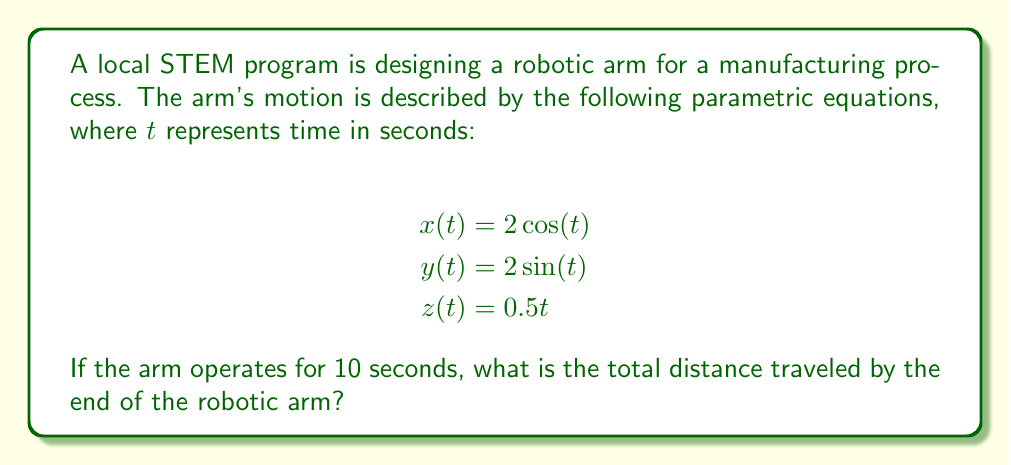Give your solution to this math problem. To solve this problem, we need to follow these steps:

1) The parametric equations describe a helical path in 3D space. We need to calculate the length of this path.

2) For a parametric curve, the arc length $L$ from $t=a$ to $t=b$ is given by:

   $$L = \int_a^b \sqrt{\left(\frac{dx}{dt}\right)^2 + \left(\frac{dy}{dt}\right)^2 + \left(\frac{dz}{dt}\right)^2} dt$$

3) Let's calculate the derivatives:
   $$\frac{dx}{dt} = -2\sin(t)$$
   $$\frac{dy}{dt} = 2\cos(t)$$
   $$\frac{dz}{dt} = 0.5$$

4) Now, let's substitute these into our integral:

   $$L = \int_0^{10} \sqrt{(-2\sin(t))^2 + (2\cos(t))^2 + (0.5)^2} dt$$

5) Simplify under the square root:
   $$L = \int_0^{10} \sqrt{4\sin^2(t) + 4\cos^2(t) + 0.25} dt$$

6) Recall that $\sin^2(t) + \cos^2(t) = 1$, so:
   $$L = \int_0^{10} \sqrt{4 + 0.25} dt = \int_0^{10} \sqrt{4.25} dt = \int_0^{10} 2.0616 dt$$

7) Now we can evaluate the integral:
   $$L = 2.0616t \bigg|_0^{10} = 2.0616 \cdot 10 - 0 = 20.616$$

Therefore, the total distance traveled by the end of the robotic arm is approximately 20.616 units.
Answer: 20.616 units 